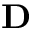Convert formula to latex. <formula><loc_0><loc_0><loc_500><loc_500>D</formula> 